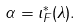<formula> <loc_0><loc_0><loc_500><loc_500>\alpha = \iota _ { F } ^ { * } ( \lambda ) .</formula> 